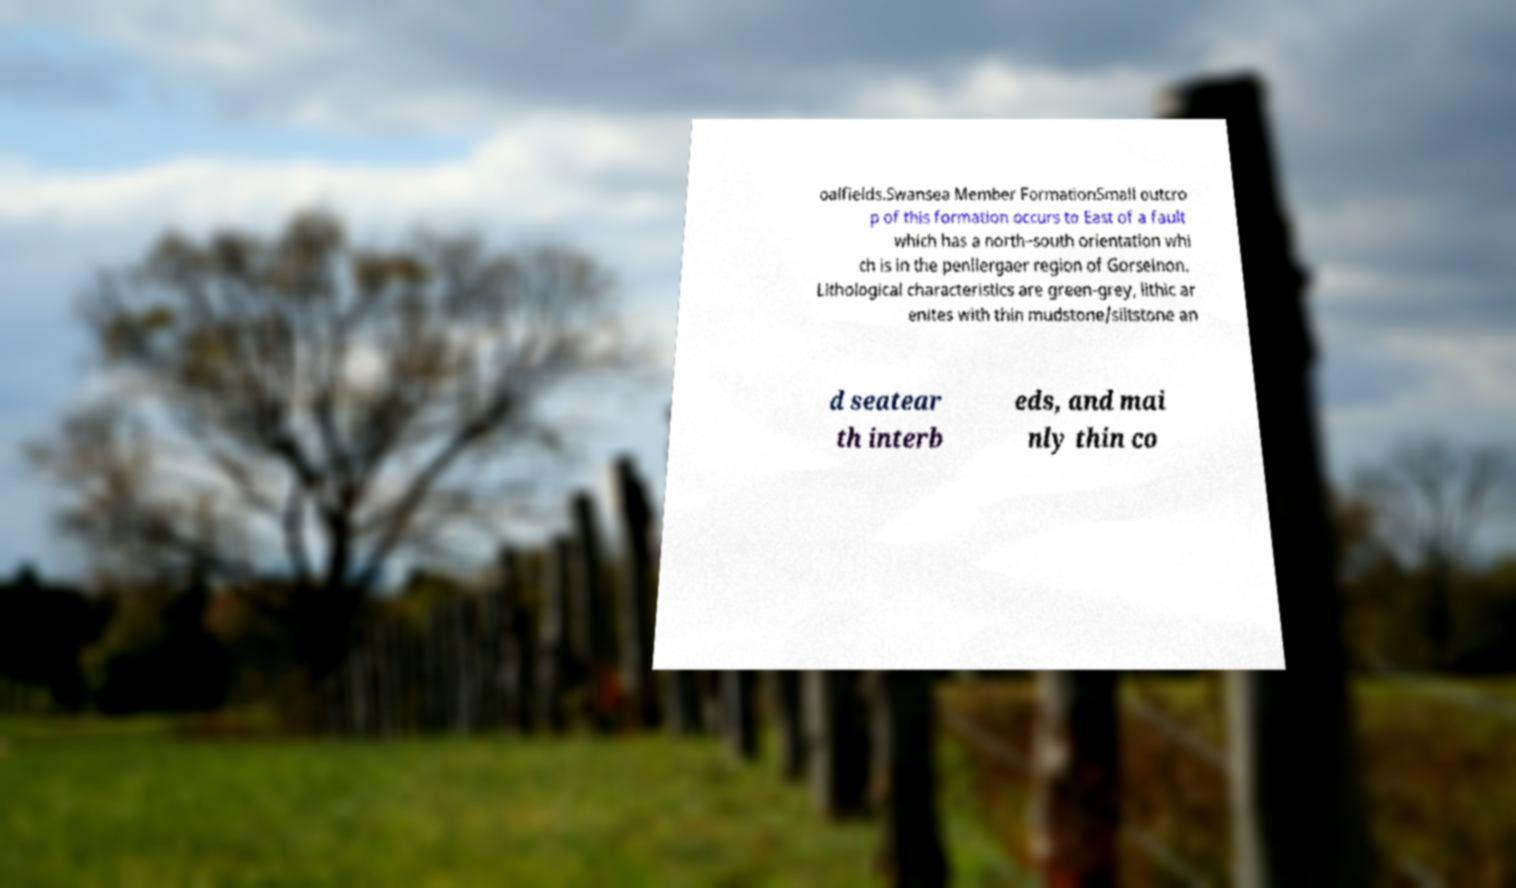Please identify and transcribe the text found in this image. oalfields.Swansea Member FormationSmall outcro p of this formation occurs to East of a fault which has a north–south orientation whi ch is in the penllergaer region of Gorseinon. Lithological characteristics are green-grey, lithic ar enites with thin mudstone/siltstone an d seatear th interb eds, and mai nly thin co 